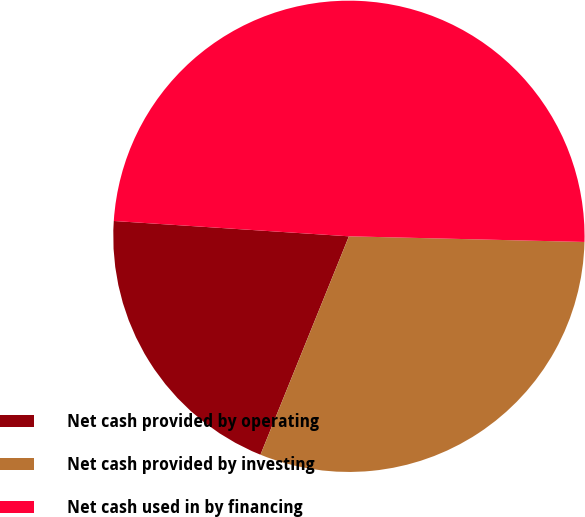Convert chart. <chart><loc_0><loc_0><loc_500><loc_500><pie_chart><fcel>Net cash provided by operating<fcel>Net cash provided by investing<fcel>Net cash used in by financing<nl><fcel>19.91%<fcel>30.74%<fcel>49.34%<nl></chart> 